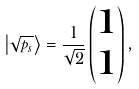<formula> <loc_0><loc_0><loc_500><loc_500>\left | \sqrt { p _ { s } } \right \rangle = \frac { 1 } { \sqrt { 2 } } \begin{pmatrix} 1 \\ 1 \end{pmatrix} ,</formula> 